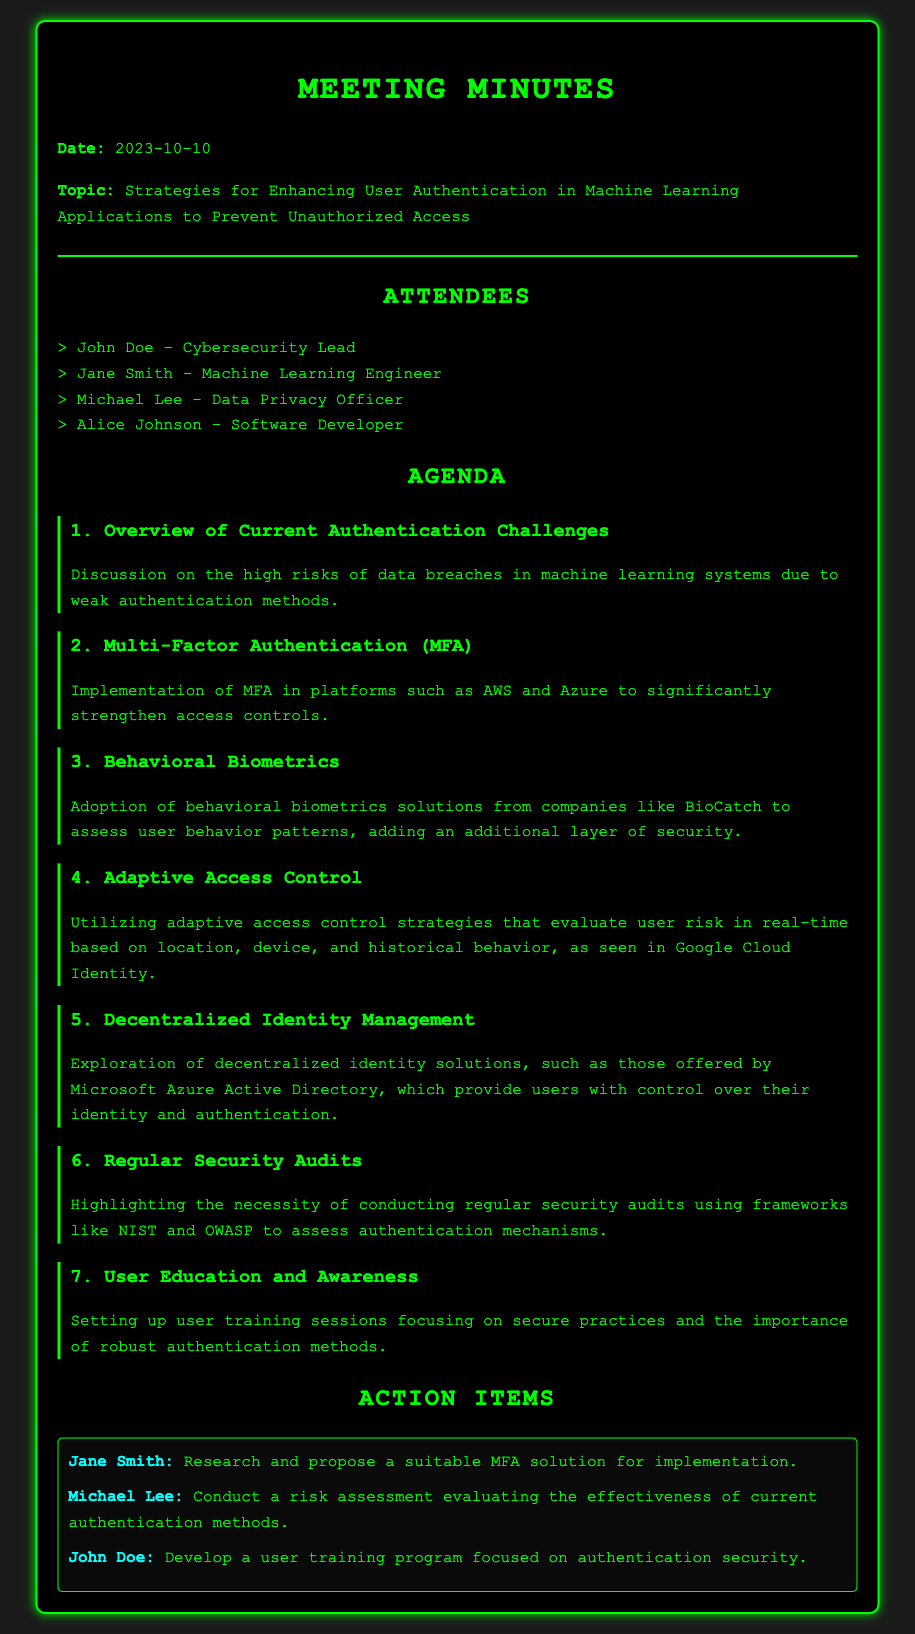What is the date of the meeting? The meeting date is mentioned at the beginning of the document under the header.
Answer: 2023-10-10 Who is the Cybersecurity Lead? The name of the Cybersecurity Lead is listed in the attendees section of the document.
Answer: John Doe What is one of the proposed topics for enhancing authentication? The agenda item highlights various strategies discussed for enhancing user authentication.
Answer: Multi-Factor Authentication What company’s solution is being discussed for behavioral biometrics? The discussion includes a specific company known for its behavioral biometrics solution.
Answer: BioCatch What action item is assigned to Michael Lee? The action items section outlines the responsibilities assigned to attendees after the meeting.
Answer: Conduct a risk assessment evaluating the effectiveness of current authentication methods How many main agenda items were discussed? By counting the listed agenda items in the document, we arrive at the total.
Answer: Seven Which framework is suggested for conducting regular security audits? One of the agenda items specifically mentions a framework relevant for security audits.
Answer: NIST What is the purpose of the user training sessions mentioned? The document outlines the aim of setting up user training sessions as part of user education strategies.
Answer: Secure practices and the importance of robust authentication methods What type of authentication does adaptive access control assess? Adaptive access control evaluates users based on specific criteria outlined in the agenda.
Answer: Risk in real-time based on location, device, and historical behavior 